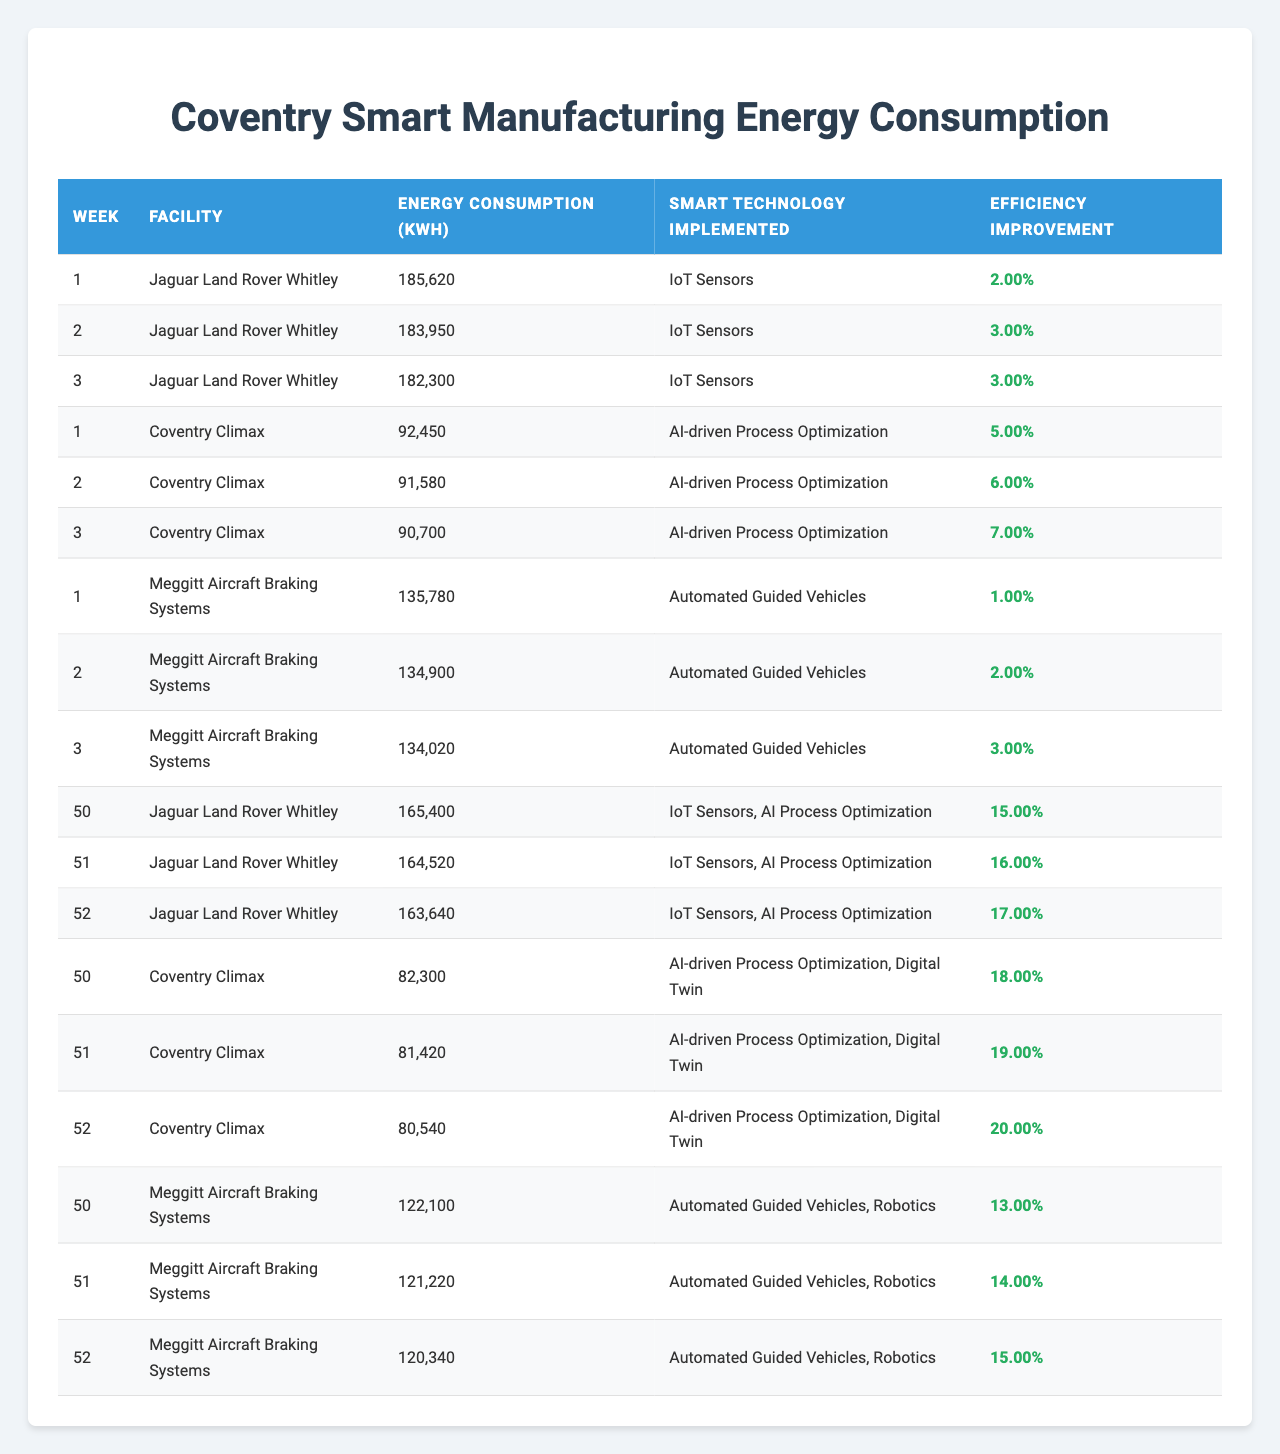What is the highest energy consumption recorded in the table? To find the highest energy consumption, I look through all the entries in the table and identify that Jaguar Land Rover Whitley recorded the highest at 185,620 kWh in week 1.
Answer: 185620 kWh Which facility implemented IoT Sensors in week 1? I check the entries for week 1 and see that Jaguar Land Rover Whitley is the only facility that implemented IoT Sensors during that week.
Answer: Jaguar Land Rover Whitley What was the efficiency improvement percentage for Coventry Climax in week 2? Looking at the data for Coventry Climax in week 2, the efficiency improvement percentage is recorded as 6%.
Answer: 6% How much energy consumption did Meggitt Aircraft Braking Systems have in week 3? I refer to week 3, where Meggitt Aircraft Braking Systems reported an energy consumption of 134,020 kWh.
Answer: 134020 kWh What is the average energy consumption for Jaguar Land Rover Whitley over the last three weeks? I sum the energy consumption for Jaguar Land Rover Whitley over the last three weeks (165,400 + 164,520 + 163,640 = 493,560 kWh) and divide by 3 to get the average (493,560 / 3 = 164,520 kWh).
Answer: 164520 kWh Did Coventry Climax's energy consumption decrease in the last three weeks? I compare the energy consumption values for Coventry Climax over the last three weeks: Week 50 was 82,300 kWh, week 51 was 81,420 kWh, and week 52 was 80,540 kWh. Since these values are decreasing, the answer is yes.
Answer: Yes What was the overall efficiency improvement for Meggitt Aircraft Braking Systems from week 50 to week 52? I check the efficiency improvements: Week 50 was 13%, week 51 was 14%, and week 52 was 15%. Therefore, the efficiency improvement from week 50 to 52 is (15% - 13% = 2%).
Answer: 2% Which technology led to the highest efficiency improvement for any facility? I scan through the efficiency improvement data and notice that in week 52, Coventry Climax achieved a 20% improvement with AI-driven Process Optimization and Digital Twin, which is the highest recorded.
Answer: 20% How did the energy consumption of Jaguar Land Rover Whitley change from week 1 to week 52? I look at the energy consumption values: Week 1 was 185,620 kWh and week 52 was 163,640 kWh. To find the change, I subtract week 52 from week 1 (185,620 - 163,640 = 21,980 kWh), showing a decrease.
Answer: Decreased by 21980 kWh Is there any facility that maintained the same smart technology throughout the observations? I review each facility’s entries and see that Jaguar Land Rover Whitley consistently used IoT Sensors for the first 49 weeks, showing stability in smart technology use.
Answer: Yes, Jaguar Land Rover Whitley Which facility experienced a larger percentage drop in energy consumption from the first week to the last week? I calculate for Jaguar Land Rover Whitley: (185,620 - 163,640) / 185,620 = 0.118 (11.8% drop). For Coventry Climax: (92,450 - 80,540) / 92,450 = 0.128 (12.8% drop). Hence, Coventry Climax had a larger percentage drop than Jaguar Land Rover Whitley.
Answer: Coventry Climax 